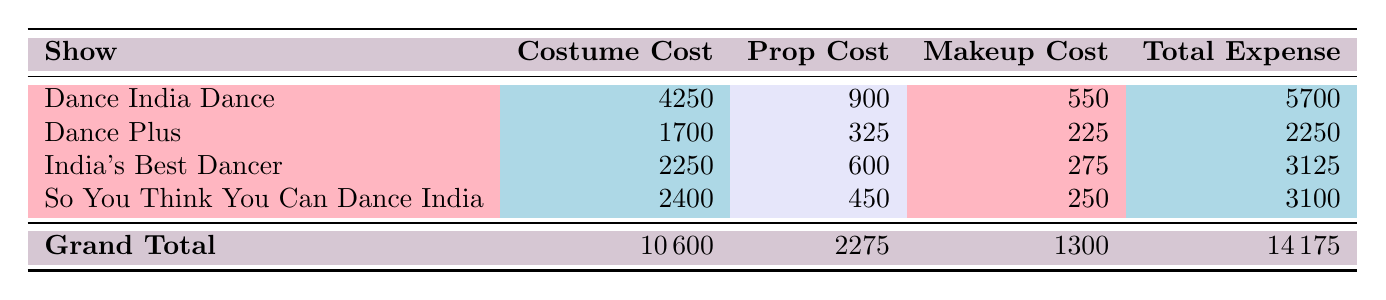What is the total costume cost for all shows combined? To find the total costume cost, add together the costume costs from each show: 4250 + 1700 + 2250 + 2400 = 10600.
Answer: 10600 Which show has the highest total expense? The total expenses for each show are: Dance India Dance - 5700, Dance Plus - 2250, India's Best Dancer - 3125, So You Think You Can Dance India - 3100. Dance India Dance has the highest total expense of 5700.
Answer: Dance India Dance What is the total prop cost for Dance Plus? The table shows that the prop cost for Dance Plus is 325. Therefore, the total prop cost is directly taken from the table.
Answer: 325 True or False: The total expense for Vartika Jha across all episodes is less than 4000. To evaluate this, sum Vartika Jha's total expenses: 1650 + 1000 + 1225 + 1825 = 4700. Since 4700 is greater than 4000, the statement is false.
Answer: False What is the average makeup cost across all shows? First, sum all the makeup costs: 550 + 225 + 275 + 250 = 1300. Then, divide by the number of entries (4): 1300 / 4 = 325.
Answer: 325 Which show's total expenses are closest to 3000? The total expenses for each show are: Dance India Dance - 5700, Dance Plus - 2250, India's Best Dancer - 3125, So You Think You Can Dance India - 3100. The closest to 3000 is India's Best Dancer with a total expense of 3125.
Answer: India's Best Dancer What is the difference between the total makeup costs of Dance Plus and So You Think You Can Dance India? For Dance Plus, the makeup cost is 225, and for So You Think You Can Dance India, it is 250. The difference is calculated as 250 - 225 = 25.
Answer: 25 How much more is the total expense for India's Best Dancer compared to So You Think You Can Dance India? The total expense for India's Best Dancer is 3125 and for So You Think You Can Dance India is 3100. To find the difference, subtract: 3125 - 3100 = 25.
Answer: 25 